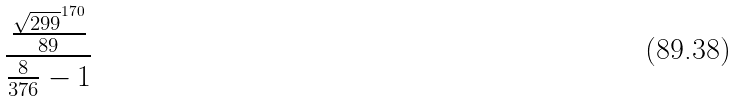Convert formula to latex. <formula><loc_0><loc_0><loc_500><loc_500>\frac { \frac { \sqrt { 2 9 9 } ^ { 1 7 0 } } { 8 9 } } { \frac { 8 } { 3 7 6 } - 1 }</formula> 